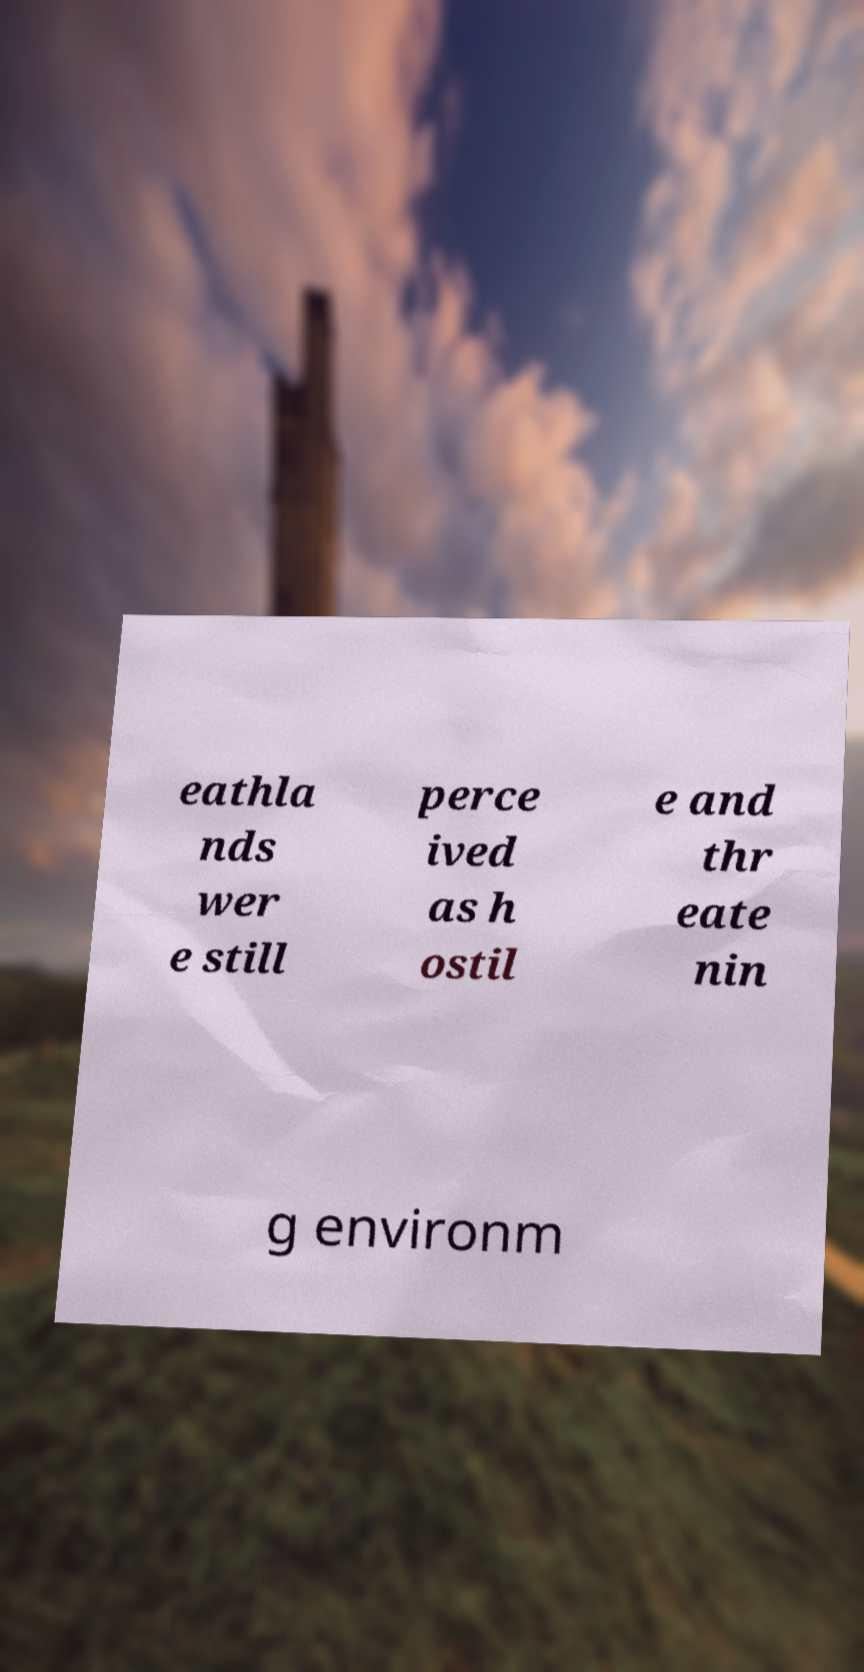Could you assist in decoding the text presented in this image and type it out clearly? eathla nds wer e still perce ived as h ostil e and thr eate nin g environm 